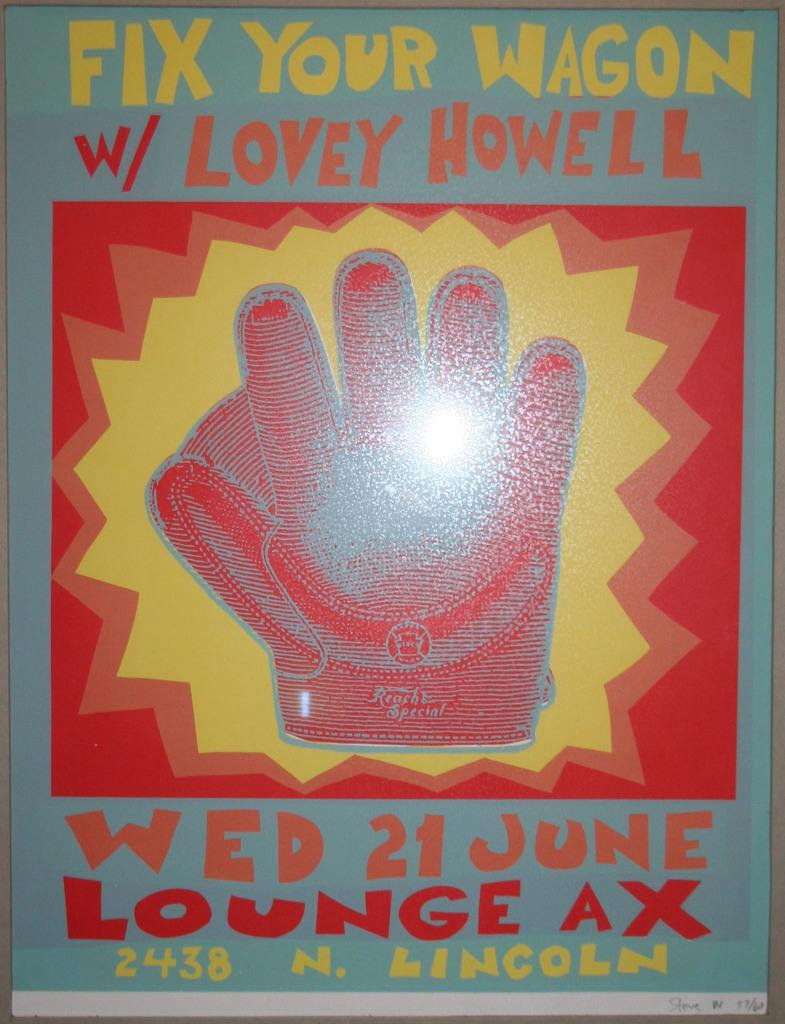What is present in the image that contains both images and text? There is a poster in the image that contains images and text. What type of rhythm can be heard from the poster in the image? There is no rhythm present in the image, as it is a static poster containing images and text. 